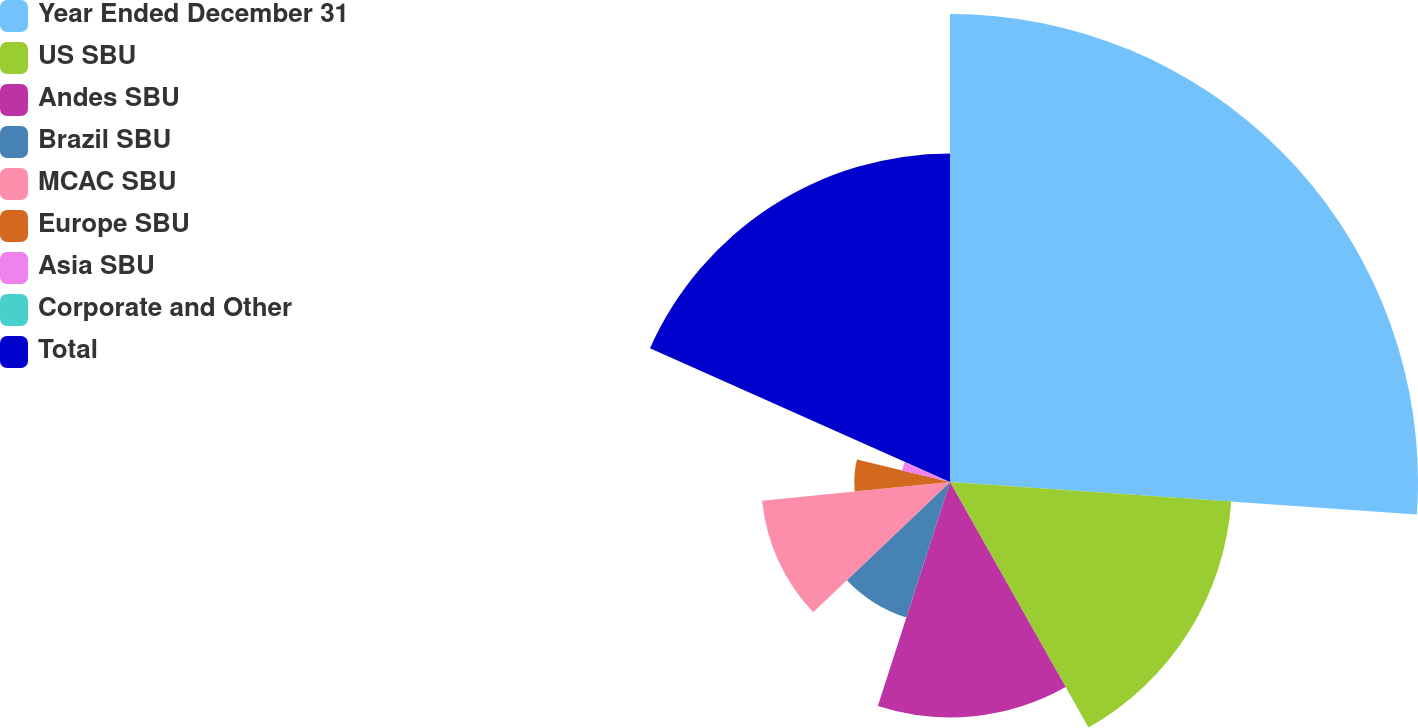Convert chart. <chart><loc_0><loc_0><loc_500><loc_500><pie_chart><fcel>Year Ended December 31<fcel>US SBU<fcel>Andes SBU<fcel>Brazil SBU<fcel>MCAC SBU<fcel>Europe SBU<fcel>Asia SBU<fcel>Corporate and Other<fcel>Total<nl><fcel>26.1%<fcel>15.72%<fcel>13.13%<fcel>7.94%<fcel>10.53%<fcel>5.34%<fcel>2.75%<fcel>0.16%<fcel>18.32%<nl></chart> 